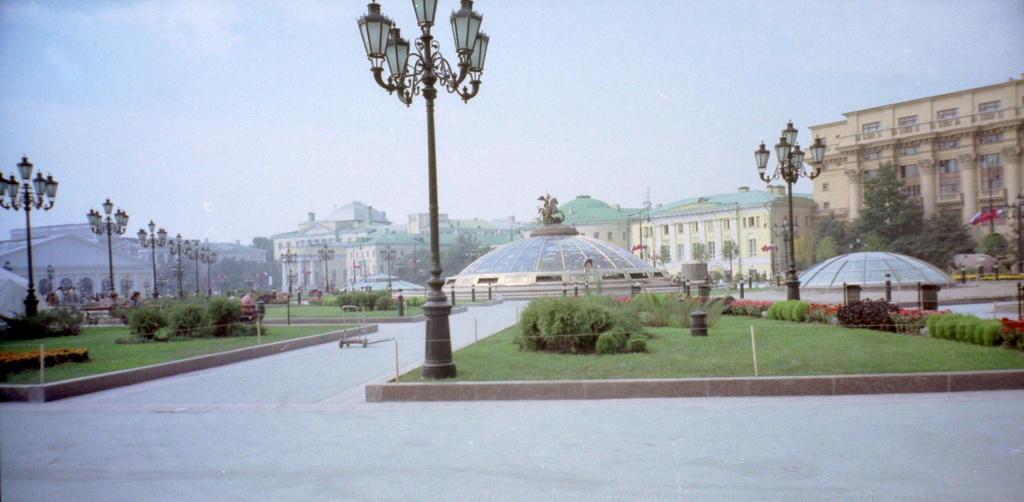Describe this image in one or two sentences. In this image there is a road. There is grass. There are trees and buildings. There are street lights. I think there are mountains in the background. There is a fountain in the middle. There is a sky. 